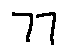Convert formula to latex. <formula><loc_0><loc_0><loc_500><loc_500>7 7</formula> 